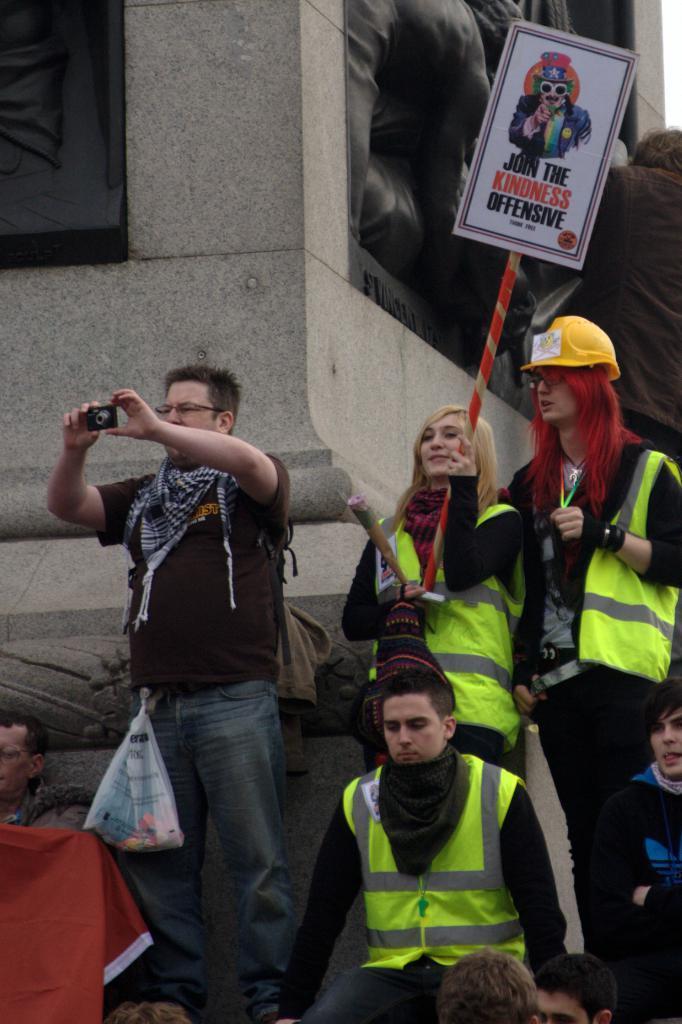In one or two sentences, can you explain what this image depicts? In this image there are a few people in which one of them is holding a camera and capturing a photo, one of them is holding a placard with some text, there are sculptures on the walls of the building. 